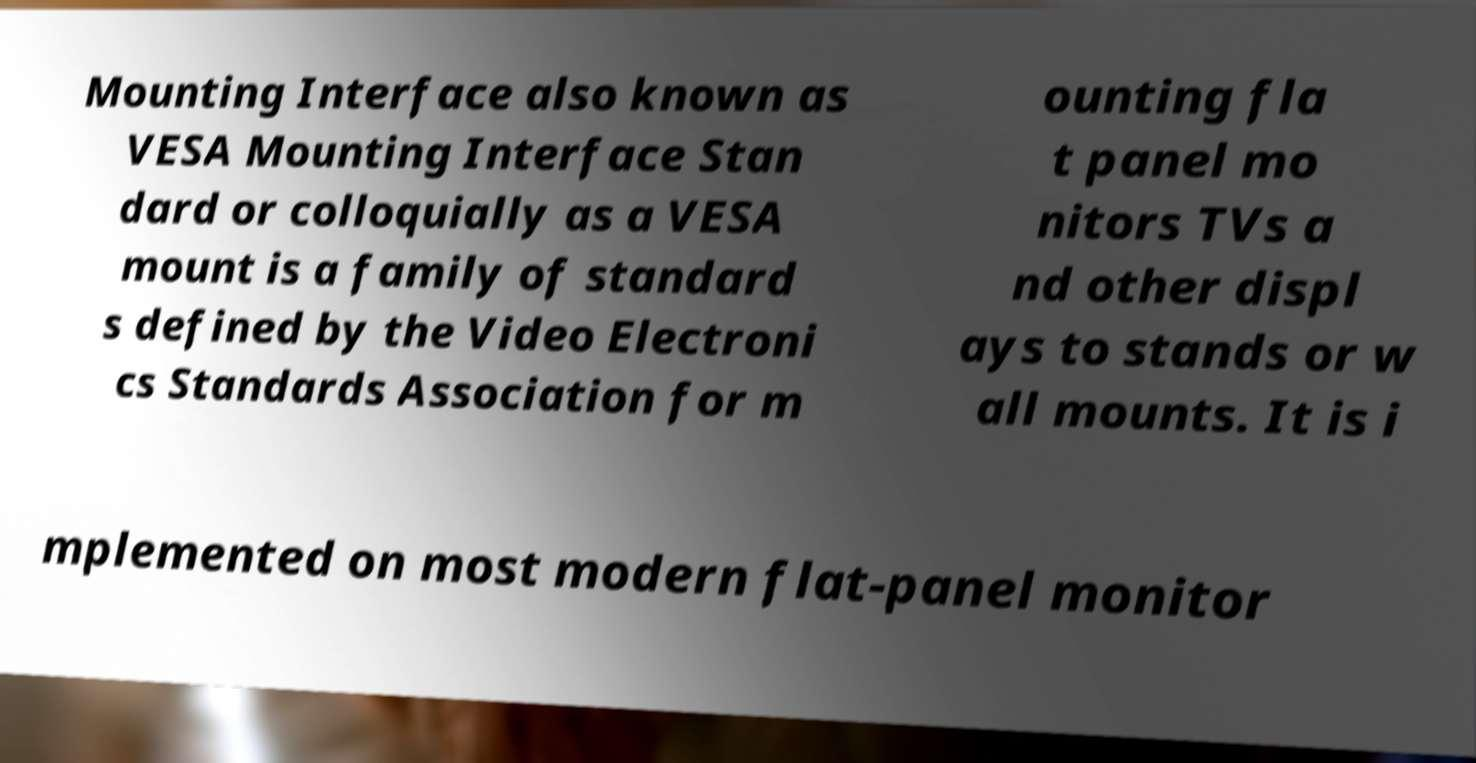Could you extract and type out the text from this image? Mounting Interface also known as VESA Mounting Interface Stan dard or colloquially as a VESA mount is a family of standard s defined by the Video Electroni cs Standards Association for m ounting fla t panel mo nitors TVs a nd other displ ays to stands or w all mounts. It is i mplemented on most modern flat-panel monitor 